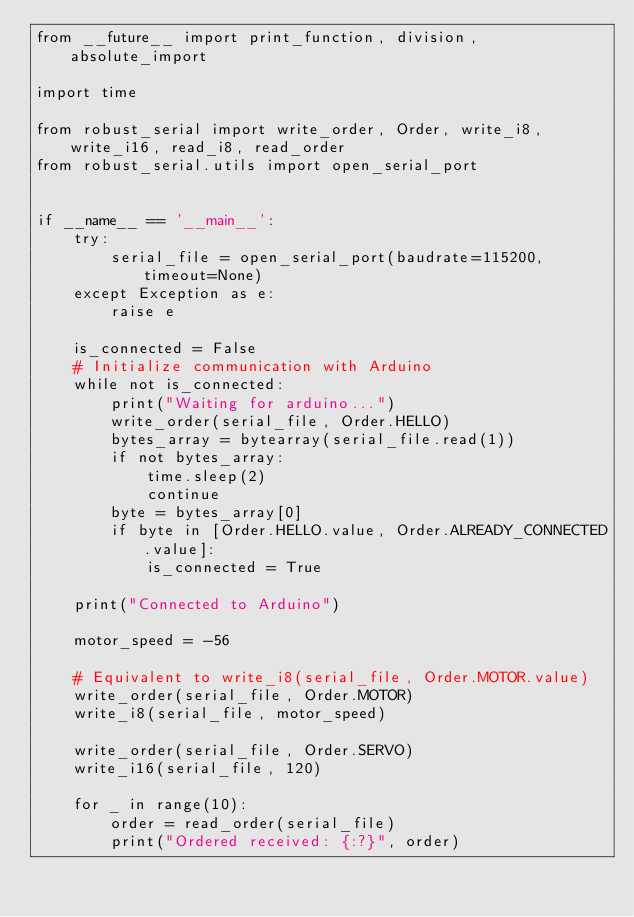Convert code to text. <code><loc_0><loc_0><loc_500><loc_500><_Python_>from __future__ import print_function, division, absolute_import

import time

from robust_serial import write_order, Order, write_i8, write_i16, read_i8, read_order
from robust_serial.utils import open_serial_port


if __name__ == '__main__':
    try:
        serial_file = open_serial_port(baudrate=115200, timeout=None)
    except Exception as e:
        raise e

    is_connected = False
    # Initialize communication with Arduino
    while not is_connected:
        print("Waiting for arduino...")
        write_order(serial_file, Order.HELLO)
        bytes_array = bytearray(serial_file.read(1))
        if not bytes_array:
            time.sleep(2)
            continue
        byte = bytes_array[0]
        if byte in [Order.HELLO.value, Order.ALREADY_CONNECTED.value]:
            is_connected = True

    print("Connected to Arduino")

    motor_speed = -56

    # Equivalent to write_i8(serial_file, Order.MOTOR.value)
    write_order(serial_file, Order.MOTOR)
    write_i8(serial_file, motor_speed)

    write_order(serial_file, Order.SERVO)
    write_i16(serial_file, 120)

    for _ in range(10):
        order = read_order(serial_file)
        print("Ordered received: {:?}", order)
</code> 